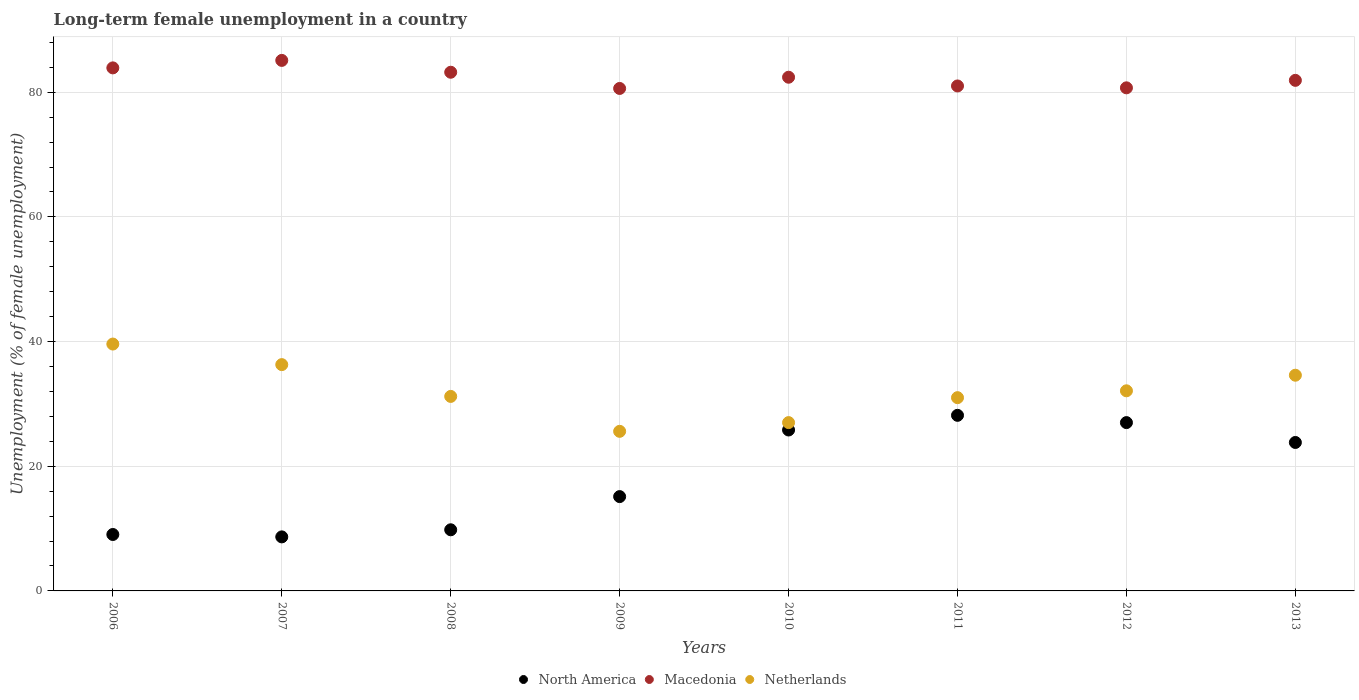How many different coloured dotlines are there?
Make the answer very short. 3. Is the number of dotlines equal to the number of legend labels?
Keep it short and to the point. Yes. What is the percentage of long-term unemployed female population in Macedonia in 2009?
Keep it short and to the point. 80.6. Across all years, what is the maximum percentage of long-term unemployed female population in Macedonia?
Your response must be concise. 85.1. Across all years, what is the minimum percentage of long-term unemployed female population in North America?
Your response must be concise. 8.67. In which year was the percentage of long-term unemployed female population in Netherlands maximum?
Your answer should be very brief. 2006. What is the total percentage of long-term unemployed female population in North America in the graph?
Your response must be concise. 147.45. What is the difference between the percentage of long-term unemployed female population in North America in 2010 and that in 2011?
Give a very brief answer. -2.35. What is the difference between the percentage of long-term unemployed female population in North America in 2006 and the percentage of long-term unemployed female population in Netherlands in 2008?
Your answer should be very brief. -22.15. What is the average percentage of long-term unemployed female population in Netherlands per year?
Ensure brevity in your answer.  32.17. In the year 2007, what is the difference between the percentage of long-term unemployed female population in Netherlands and percentage of long-term unemployed female population in North America?
Your answer should be very brief. 27.63. In how many years, is the percentage of long-term unemployed female population in North America greater than 32 %?
Your answer should be very brief. 0. What is the ratio of the percentage of long-term unemployed female population in Netherlands in 2012 to that in 2013?
Provide a short and direct response. 0.93. Is the percentage of long-term unemployed female population in Netherlands in 2006 less than that in 2012?
Your answer should be very brief. No. What is the difference between the highest and the second highest percentage of long-term unemployed female population in North America?
Offer a very short reply. 1.17. What is the difference between the highest and the lowest percentage of long-term unemployed female population in Netherlands?
Give a very brief answer. 14. Is the sum of the percentage of long-term unemployed female population in North America in 2008 and 2013 greater than the maximum percentage of long-term unemployed female population in Netherlands across all years?
Your response must be concise. No. Is the percentage of long-term unemployed female population in North America strictly less than the percentage of long-term unemployed female population in Macedonia over the years?
Provide a short and direct response. Yes. What is the difference between two consecutive major ticks on the Y-axis?
Offer a terse response. 20. Are the values on the major ticks of Y-axis written in scientific E-notation?
Keep it short and to the point. No. Does the graph contain any zero values?
Your answer should be very brief. No. Where does the legend appear in the graph?
Ensure brevity in your answer.  Bottom center. How many legend labels are there?
Provide a short and direct response. 3. How are the legend labels stacked?
Your answer should be compact. Horizontal. What is the title of the graph?
Make the answer very short. Long-term female unemployment in a country. What is the label or title of the Y-axis?
Provide a short and direct response. Unemployment (% of female unemployment). What is the Unemployment (% of female unemployment) in North America in 2006?
Give a very brief answer. 9.05. What is the Unemployment (% of female unemployment) in Macedonia in 2006?
Provide a short and direct response. 83.9. What is the Unemployment (% of female unemployment) in Netherlands in 2006?
Your answer should be very brief. 39.6. What is the Unemployment (% of female unemployment) of North America in 2007?
Offer a very short reply. 8.67. What is the Unemployment (% of female unemployment) in Macedonia in 2007?
Keep it short and to the point. 85.1. What is the Unemployment (% of female unemployment) of Netherlands in 2007?
Provide a succinct answer. 36.3. What is the Unemployment (% of female unemployment) in North America in 2008?
Provide a succinct answer. 9.81. What is the Unemployment (% of female unemployment) in Macedonia in 2008?
Offer a very short reply. 83.2. What is the Unemployment (% of female unemployment) in Netherlands in 2008?
Give a very brief answer. 31.2. What is the Unemployment (% of female unemployment) of North America in 2009?
Your response must be concise. 15.13. What is the Unemployment (% of female unemployment) in Macedonia in 2009?
Give a very brief answer. 80.6. What is the Unemployment (% of female unemployment) of Netherlands in 2009?
Provide a short and direct response. 25.6. What is the Unemployment (% of female unemployment) of North America in 2010?
Your answer should be very brief. 25.81. What is the Unemployment (% of female unemployment) of Macedonia in 2010?
Your response must be concise. 82.4. What is the Unemployment (% of female unemployment) in Netherlands in 2010?
Make the answer very short. 27. What is the Unemployment (% of female unemployment) in North America in 2011?
Your answer should be very brief. 28.17. What is the Unemployment (% of female unemployment) of Macedonia in 2011?
Your answer should be very brief. 81. What is the Unemployment (% of female unemployment) in North America in 2012?
Provide a succinct answer. 27. What is the Unemployment (% of female unemployment) of Macedonia in 2012?
Provide a short and direct response. 80.7. What is the Unemployment (% of female unemployment) in Netherlands in 2012?
Your answer should be compact. 32.1. What is the Unemployment (% of female unemployment) in North America in 2013?
Offer a terse response. 23.81. What is the Unemployment (% of female unemployment) of Macedonia in 2013?
Ensure brevity in your answer.  81.9. What is the Unemployment (% of female unemployment) in Netherlands in 2013?
Offer a very short reply. 34.6. Across all years, what is the maximum Unemployment (% of female unemployment) in North America?
Make the answer very short. 28.17. Across all years, what is the maximum Unemployment (% of female unemployment) in Macedonia?
Offer a terse response. 85.1. Across all years, what is the maximum Unemployment (% of female unemployment) in Netherlands?
Offer a terse response. 39.6. Across all years, what is the minimum Unemployment (% of female unemployment) of North America?
Offer a terse response. 8.67. Across all years, what is the minimum Unemployment (% of female unemployment) in Macedonia?
Provide a short and direct response. 80.6. Across all years, what is the minimum Unemployment (% of female unemployment) of Netherlands?
Provide a short and direct response. 25.6. What is the total Unemployment (% of female unemployment) of North America in the graph?
Keep it short and to the point. 147.45. What is the total Unemployment (% of female unemployment) of Macedonia in the graph?
Ensure brevity in your answer.  658.8. What is the total Unemployment (% of female unemployment) of Netherlands in the graph?
Offer a very short reply. 257.4. What is the difference between the Unemployment (% of female unemployment) of North America in 2006 and that in 2007?
Offer a terse response. 0.38. What is the difference between the Unemployment (% of female unemployment) of Macedonia in 2006 and that in 2007?
Your answer should be very brief. -1.2. What is the difference between the Unemployment (% of female unemployment) in Netherlands in 2006 and that in 2007?
Provide a short and direct response. 3.3. What is the difference between the Unemployment (% of female unemployment) in North America in 2006 and that in 2008?
Your answer should be compact. -0.75. What is the difference between the Unemployment (% of female unemployment) of North America in 2006 and that in 2009?
Offer a terse response. -6.08. What is the difference between the Unemployment (% of female unemployment) of Macedonia in 2006 and that in 2009?
Your answer should be compact. 3.3. What is the difference between the Unemployment (% of female unemployment) of North America in 2006 and that in 2010?
Your answer should be very brief. -16.76. What is the difference between the Unemployment (% of female unemployment) in North America in 2006 and that in 2011?
Offer a very short reply. -19.11. What is the difference between the Unemployment (% of female unemployment) in North America in 2006 and that in 2012?
Your answer should be compact. -17.95. What is the difference between the Unemployment (% of female unemployment) in Netherlands in 2006 and that in 2012?
Give a very brief answer. 7.5. What is the difference between the Unemployment (% of female unemployment) in North America in 2006 and that in 2013?
Offer a terse response. -14.76. What is the difference between the Unemployment (% of female unemployment) of Netherlands in 2006 and that in 2013?
Give a very brief answer. 5. What is the difference between the Unemployment (% of female unemployment) of North America in 2007 and that in 2008?
Offer a terse response. -1.14. What is the difference between the Unemployment (% of female unemployment) in Macedonia in 2007 and that in 2008?
Your answer should be compact. 1.9. What is the difference between the Unemployment (% of female unemployment) in Netherlands in 2007 and that in 2008?
Your answer should be very brief. 5.1. What is the difference between the Unemployment (% of female unemployment) of North America in 2007 and that in 2009?
Provide a short and direct response. -6.46. What is the difference between the Unemployment (% of female unemployment) in North America in 2007 and that in 2010?
Offer a very short reply. -17.15. What is the difference between the Unemployment (% of female unemployment) in Macedonia in 2007 and that in 2010?
Keep it short and to the point. 2.7. What is the difference between the Unemployment (% of female unemployment) in North America in 2007 and that in 2011?
Give a very brief answer. -19.5. What is the difference between the Unemployment (% of female unemployment) of North America in 2007 and that in 2012?
Your answer should be compact. -18.33. What is the difference between the Unemployment (% of female unemployment) in North America in 2007 and that in 2013?
Give a very brief answer. -15.14. What is the difference between the Unemployment (% of female unemployment) of Macedonia in 2007 and that in 2013?
Offer a very short reply. 3.2. What is the difference between the Unemployment (% of female unemployment) of Netherlands in 2007 and that in 2013?
Provide a short and direct response. 1.7. What is the difference between the Unemployment (% of female unemployment) in North America in 2008 and that in 2009?
Make the answer very short. -5.32. What is the difference between the Unemployment (% of female unemployment) of Macedonia in 2008 and that in 2009?
Ensure brevity in your answer.  2.6. What is the difference between the Unemployment (% of female unemployment) in North America in 2008 and that in 2010?
Offer a very short reply. -16.01. What is the difference between the Unemployment (% of female unemployment) in Macedonia in 2008 and that in 2010?
Your answer should be compact. 0.8. What is the difference between the Unemployment (% of female unemployment) in Netherlands in 2008 and that in 2010?
Provide a short and direct response. 4.2. What is the difference between the Unemployment (% of female unemployment) of North America in 2008 and that in 2011?
Your response must be concise. -18.36. What is the difference between the Unemployment (% of female unemployment) in Macedonia in 2008 and that in 2011?
Your response must be concise. 2.2. What is the difference between the Unemployment (% of female unemployment) of Netherlands in 2008 and that in 2011?
Keep it short and to the point. 0.2. What is the difference between the Unemployment (% of female unemployment) in North America in 2008 and that in 2012?
Your answer should be compact. -17.19. What is the difference between the Unemployment (% of female unemployment) in Macedonia in 2008 and that in 2012?
Make the answer very short. 2.5. What is the difference between the Unemployment (% of female unemployment) in North America in 2008 and that in 2013?
Provide a short and direct response. -14.01. What is the difference between the Unemployment (% of female unemployment) of Netherlands in 2008 and that in 2013?
Provide a succinct answer. -3.4. What is the difference between the Unemployment (% of female unemployment) of North America in 2009 and that in 2010?
Your response must be concise. -10.69. What is the difference between the Unemployment (% of female unemployment) of Netherlands in 2009 and that in 2010?
Your response must be concise. -1.4. What is the difference between the Unemployment (% of female unemployment) of North America in 2009 and that in 2011?
Offer a terse response. -13.04. What is the difference between the Unemployment (% of female unemployment) of Macedonia in 2009 and that in 2011?
Your response must be concise. -0.4. What is the difference between the Unemployment (% of female unemployment) in North America in 2009 and that in 2012?
Your answer should be very brief. -11.87. What is the difference between the Unemployment (% of female unemployment) of Netherlands in 2009 and that in 2012?
Offer a terse response. -6.5. What is the difference between the Unemployment (% of female unemployment) of North America in 2009 and that in 2013?
Your answer should be compact. -8.68. What is the difference between the Unemployment (% of female unemployment) in Netherlands in 2009 and that in 2013?
Offer a very short reply. -9. What is the difference between the Unemployment (% of female unemployment) of North America in 2010 and that in 2011?
Your answer should be compact. -2.35. What is the difference between the Unemployment (% of female unemployment) of Netherlands in 2010 and that in 2011?
Make the answer very short. -4. What is the difference between the Unemployment (% of female unemployment) in North America in 2010 and that in 2012?
Keep it short and to the point. -1.18. What is the difference between the Unemployment (% of female unemployment) in Netherlands in 2010 and that in 2012?
Ensure brevity in your answer.  -5.1. What is the difference between the Unemployment (% of female unemployment) of North America in 2010 and that in 2013?
Provide a short and direct response. 2. What is the difference between the Unemployment (% of female unemployment) of North America in 2011 and that in 2012?
Your answer should be compact. 1.17. What is the difference between the Unemployment (% of female unemployment) of North America in 2011 and that in 2013?
Offer a terse response. 4.35. What is the difference between the Unemployment (% of female unemployment) of North America in 2012 and that in 2013?
Ensure brevity in your answer.  3.19. What is the difference between the Unemployment (% of female unemployment) in Macedonia in 2012 and that in 2013?
Give a very brief answer. -1.2. What is the difference between the Unemployment (% of female unemployment) of Netherlands in 2012 and that in 2013?
Offer a very short reply. -2.5. What is the difference between the Unemployment (% of female unemployment) in North America in 2006 and the Unemployment (% of female unemployment) in Macedonia in 2007?
Your answer should be very brief. -76.05. What is the difference between the Unemployment (% of female unemployment) of North America in 2006 and the Unemployment (% of female unemployment) of Netherlands in 2007?
Your answer should be compact. -27.25. What is the difference between the Unemployment (% of female unemployment) of Macedonia in 2006 and the Unemployment (% of female unemployment) of Netherlands in 2007?
Your answer should be compact. 47.6. What is the difference between the Unemployment (% of female unemployment) of North America in 2006 and the Unemployment (% of female unemployment) of Macedonia in 2008?
Provide a succinct answer. -74.15. What is the difference between the Unemployment (% of female unemployment) of North America in 2006 and the Unemployment (% of female unemployment) of Netherlands in 2008?
Provide a short and direct response. -22.15. What is the difference between the Unemployment (% of female unemployment) of Macedonia in 2006 and the Unemployment (% of female unemployment) of Netherlands in 2008?
Give a very brief answer. 52.7. What is the difference between the Unemployment (% of female unemployment) of North America in 2006 and the Unemployment (% of female unemployment) of Macedonia in 2009?
Provide a short and direct response. -71.55. What is the difference between the Unemployment (% of female unemployment) of North America in 2006 and the Unemployment (% of female unemployment) of Netherlands in 2009?
Make the answer very short. -16.55. What is the difference between the Unemployment (% of female unemployment) of Macedonia in 2006 and the Unemployment (% of female unemployment) of Netherlands in 2009?
Offer a very short reply. 58.3. What is the difference between the Unemployment (% of female unemployment) in North America in 2006 and the Unemployment (% of female unemployment) in Macedonia in 2010?
Provide a short and direct response. -73.35. What is the difference between the Unemployment (% of female unemployment) of North America in 2006 and the Unemployment (% of female unemployment) of Netherlands in 2010?
Your answer should be compact. -17.95. What is the difference between the Unemployment (% of female unemployment) of Macedonia in 2006 and the Unemployment (% of female unemployment) of Netherlands in 2010?
Provide a short and direct response. 56.9. What is the difference between the Unemployment (% of female unemployment) in North America in 2006 and the Unemployment (% of female unemployment) in Macedonia in 2011?
Provide a succinct answer. -71.95. What is the difference between the Unemployment (% of female unemployment) of North America in 2006 and the Unemployment (% of female unemployment) of Netherlands in 2011?
Give a very brief answer. -21.95. What is the difference between the Unemployment (% of female unemployment) in Macedonia in 2006 and the Unemployment (% of female unemployment) in Netherlands in 2011?
Provide a succinct answer. 52.9. What is the difference between the Unemployment (% of female unemployment) in North America in 2006 and the Unemployment (% of female unemployment) in Macedonia in 2012?
Give a very brief answer. -71.65. What is the difference between the Unemployment (% of female unemployment) of North America in 2006 and the Unemployment (% of female unemployment) of Netherlands in 2012?
Your response must be concise. -23.05. What is the difference between the Unemployment (% of female unemployment) of Macedonia in 2006 and the Unemployment (% of female unemployment) of Netherlands in 2012?
Ensure brevity in your answer.  51.8. What is the difference between the Unemployment (% of female unemployment) in North America in 2006 and the Unemployment (% of female unemployment) in Macedonia in 2013?
Give a very brief answer. -72.85. What is the difference between the Unemployment (% of female unemployment) in North America in 2006 and the Unemployment (% of female unemployment) in Netherlands in 2013?
Provide a short and direct response. -25.55. What is the difference between the Unemployment (% of female unemployment) of Macedonia in 2006 and the Unemployment (% of female unemployment) of Netherlands in 2013?
Give a very brief answer. 49.3. What is the difference between the Unemployment (% of female unemployment) of North America in 2007 and the Unemployment (% of female unemployment) of Macedonia in 2008?
Offer a terse response. -74.53. What is the difference between the Unemployment (% of female unemployment) of North America in 2007 and the Unemployment (% of female unemployment) of Netherlands in 2008?
Your answer should be compact. -22.53. What is the difference between the Unemployment (% of female unemployment) of Macedonia in 2007 and the Unemployment (% of female unemployment) of Netherlands in 2008?
Your answer should be very brief. 53.9. What is the difference between the Unemployment (% of female unemployment) in North America in 2007 and the Unemployment (% of female unemployment) in Macedonia in 2009?
Provide a succinct answer. -71.93. What is the difference between the Unemployment (% of female unemployment) in North America in 2007 and the Unemployment (% of female unemployment) in Netherlands in 2009?
Ensure brevity in your answer.  -16.93. What is the difference between the Unemployment (% of female unemployment) in Macedonia in 2007 and the Unemployment (% of female unemployment) in Netherlands in 2009?
Keep it short and to the point. 59.5. What is the difference between the Unemployment (% of female unemployment) of North America in 2007 and the Unemployment (% of female unemployment) of Macedonia in 2010?
Your answer should be compact. -73.73. What is the difference between the Unemployment (% of female unemployment) in North America in 2007 and the Unemployment (% of female unemployment) in Netherlands in 2010?
Provide a succinct answer. -18.33. What is the difference between the Unemployment (% of female unemployment) of Macedonia in 2007 and the Unemployment (% of female unemployment) of Netherlands in 2010?
Keep it short and to the point. 58.1. What is the difference between the Unemployment (% of female unemployment) in North America in 2007 and the Unemployment (% of female unemployment) in Macedonia in 2011?
Offer a terse response. -72.33. What is the difference between the Unemployment (% of female unemployment) in North America in 2007 and the Unemployment (% of female unemployment) in Netherlands in 2011?
Your answer should be compact. -22.33. What is the difference between the Unemployment (% of female unemployment) in Macedonia in 2007 and the Unemployment (% of female unemployment) in Netherlands in 2011?
Provide a succinct answer. 54.1. What is the difference between the Unemployment (% of female unemployment) in North America in 2007 and the Unemployment (% of female unemployment) in Macedonia in 2012?
Keep it short and to the point. -72.03. What is the difference between the Unemployment (% of female unemployment) in North America in 2007 and the Unemployment (% of female unemployment) in Netherlands in 2012?
Keep it short and to the point. -23.43. What is the difference between the Unemployment (% of female unemployment) in North America in 2007 and the Unemployment (% of female unemployment) in Macedonia in 2013?
Provide a succinct answer. -73.23. What is the difference between the Unemployment (% of female unemployment) in North America in 2007 and the Unemployment (% of female unemployment) in Netherlands in 2013?
Your answer should be compact. -25.93. What is the difference between the Unemployment (% of female unemployment) of Macedonia in 2007 and the Unemployment (% of female unemployment) of Netherlands in 2013?
Provide a short and direct response. 50.5. What is the difference between the Unemployment (% of female unemployment) of North America in 2008 and the Unemployment (% of female unemployment) of Macedonia in 2009?
Keep it short and to the point. -70.79. What is the difference between the Unemployment (% of female unemployment) of North America in 2008 and the Unemployment (% of female unemployment) of Netherlands in 2009?
Offer a terse response. -15.79. What is the difference between the Unemployment (% of female unemployment) in Macedonia in 2008 and the Unemployment (% of female unemployment) in Netherlands in 2009?
Your response must be concise. 57.6. What is the difference between the Unemployment (% of female unemployment) of North America in 2008 and the Unemployment (% of female unemployment) of Macedonia in 2010?
Make the answer very short. -72.59. What is the difference between the Unemployment (% of female unemployment) of North America in 2008 and the Unemployment (% of female unemployment) of Netherlands in 2010?
Your answer should be very brief. -17.19. What is the difference between the Unemployment (% of female unemployment) in Macedonia in 2008 and the Unemployment (% of female unemployment) in Netherlands in 2010?
Offer a terse response. 56.2. What is the difference between the Unemployment (% of female unemployment) of North America in 2008 and the Unemployment (% of female unemployment) of Macedonia in 2011?
Provide a succinct answer. -71.19. What is the difference between the Unemployment (% of female unemployment) in North America in 2008 and the Unemployment (% of female unemployment) in Netherlands in 2011?
Provide a succinct answer. -21.19. What is the difference between the Unemployment (% of female unemployment) of Macedonia in 2008 and the Unemployment (% of female unemployment) of Netherlands in 2011?
Your answer should be compact. 52.2. What is the difference between the Unemployment (% of female unemployment) of North America in 2008 and the Unemployment (% of female unemployment) of Macedonia in 2012?
Make the answer very short. -70.89. What is the difference between the Unemployment (% of female unemployment) of North America in 2008 and the Unemployment (% of female unemployment) of Netherlands in 2012?
Give a very brief answer. -22.29. What is the difference between the Unemployment (% of female unemployment) in Macedonia in 2008 and the Unemployment (% of female unemployment) in Netherlands in 2012?
Give a very brief answer. 51.1. What is the difference between the Unemployment (% of female unemployment) in North America in 2008 and the Unemployment (% of female unemployment) in Macedonia in 2013?
Ensure brevity in your answer.  -72.09. What is the difference between the Unemployment (% of female unemployment) of North America in 2008 and the Unemployment (% of female unemployment) of Netherlands in 2013?
Make the answer very short. -24.79. What is the difference between the Unemployment (% of female unemployment) in Macedonia in 2008 and the Unemployment (% of female unemployment) in Netherlands in 2013?
Your answer should be very brief. 48.6. What is the difference between the Unemployment (% of female unemployment) of North America in 2009 and the Unemployment (% of female unemployment) of Macedonia in 2010?
Your answer should be very brief. -67.27. What is the difference between the Unemployment (% of female unemployment) in North America in 2009 and the Unemployment (% of female unemployment) in Netherlands in 2010?
Give a very brief answer. -11.87. What is the difference between the Unemployment (% of female unemployment) of Macedonia in 2009 and the Unemployment (% of female unemployment) of Netherlands in 2010?
Provide a short and direct response. 53.6. What is the difference between the Unemployment (% of female unemployment) in North America in 2009 and the Unemployment (% of female unemployment) in Macedonia in 2011?
Offer a terse response. -65.87. What is the difference between the Unemployment (% of female unemployment) of North America in 2009 and the Unemployment (% of female unemployment) of Netherlands in 2011?
Your response must be concise. -15.87. What is the difference between the Unemployment (% of female unemployment) in Macedonia in 2009 and the Unemployment (% of female unemployment) in Netherlands in 2011?
Give a very brief answer. 49.6. What is the difference between the Unemployment (% of female unemployment) of North America in 2009 and the Unemployment (% of female unemployment) of Macedonia in 2012?
Offer a terse response. -65.57. What is the difference between the Unemployment (% of female unemployment) in North America in 2009 and the Unemployment (% of female unemployment) in Netherlands in 2012?
Your answer should be very brief. -16.97. What is the difference between the Unemployment (% of female unemployment) of Macedonia in 2009 and the Unemployment (% of female unemployment) of Netherlands in 2012?
Make the answer very short. 48.5. What is the difference between the Unemployment (% of female unemployment) in North America in 2009 and the Unemployment (% of female unemployment) in Macedonia in 2013?
Provide a short and direct response. -66.77. What is the difference between the Unemployment (% of female unemployment) of North America in 2009 and the Unemployment (% of female unemployment) of Netherlands in 2013?
Your answer should be compact. -19.47. What is the difference between the Unemployment (% of female unemployment) in Macedonia in 2009 and the Unemployment (% of female unemployment) in Netherlands in 2013?
Offer a terse response. 46. What is the difference between the Unemployment (% of female unemployment) in North America in 2010 and the Unemployment (% of female unemployment) in Macedonia in 2011?
Provide a succinct answer. -55.19. What is the difference between the Unemployment (% of female unemployment) in North America in 2010 and the Unemployment (% of female unemployment) in Netherlands in 2011?
Keep it short and to the point. -5.19. What is the difference between the Unemployment (% of female unemployment) in Macedonia in 2010 and the Unemployment (% of female unemployment) in Netherlands in 2011?
Keep it short and to the point. 51.4. What is the difference between the Unemployment (% of female unemployment) in North America in 2010 and the Unemployment (% of female unemployment) in Macedonia in 2012?
Offer a very short reply. -54.89. What is the difference between the Unemployment (% of female unemployment) of North America in 2010 and the Unemployment (% of female unemployment) of Netherlands in 2012?
Offer a very short reply. -6.29. What is the difference between the Unemployment (% of female unemployment) in Macedonia in 2010 and the Unemployment (% of female unemployment) in Netherlands in 2012?
Provide a succinct answer. 50.3. What is the difference between the Unemployment (% of female unemployment) in North America in 2010 and the Unemployment (% of female unemployment) in Macedonia in 2013?
Make the answer very short. -56.09. What is the difference between the Unemployment (% of female unemployment) in North America in 2010 and the Unemployment (% of female unemployment) in Netherlands in 2013?
Make the answer very short. -8.79. What is the difference between the Unemployment (% of female unemployment) in Macedonia in 2010 and the Unemployment (% of female unemployment) in Netherlands in 2013?
Offer a terse response. 47.8. What is the difference between the Unemployment (% of female unemployment) in North America in 2011 and the Unemployment (% of female unemployment) in Macedonia in 2012?
Give a very brief answer. -52.53. What is the difference between the Unemployment (% of female unemployment) of North America in 2011 and the Unemployment (% of female unemployment) of Netherlands in 2012?
Make the answer very short. -3.93. What is the difference between the Unemployment (% of female unemployment) of Macedonia in 2011 and the Unemployment (% of female unemployment) of Netherlands in 2012?
Your answer should be compact. 48.9. What is the difference between the Unemployment (% of female unemployment) of North America in 2011 and the Unemployment (% of female unemployment) of Macedonia in 2013?
Your response must be concise. -53.73. What is the difference between the Unemployment (% of female unemployment) of North America in 2011 and the Unemployment (% of female unemployment) of Netherlands in 2013?
Provide a succinct answer. -6.43. What is the difference between the Unemployment (% of female unemployment) of Macedonia in 2011 and the Unemployment (% of female unemployment) of Netherlands in 2013?
Give a very brief answer. 46.4. What is the difference between the Unemployment (% of female unemployment) in North America in 2012 and the Unemployment (% of female unemployment) in Macedonia in 2013?
Offer a very short reply. -54.9. What is the difference between the Unemployment (% of female unemployment) in North America in 2012 and the Unemployment (% of female unemployment) in Netherlands in 2013?
Provide a short and direct response. -7.6. What is the difference between the Unemployment (% of female unemployment) of Macedonia in 2012 and the Unemployment (% of female unemployment) of Netherlands in 2013?
Your answer should be compact. 46.1. What is the average Unemployment (% of female unemployment) of North America per year?
Keep it short and to the point. 18.43. What is the average Unemployment (% of female unemployment) in Macedonia per year?
Your answer should be compact. 82.35. What is the average Unemployment (% of female unemployment) in Netherlands per year?
Your response must be concise. 32.17. In the year 2006, what is the difference between the Unemployment (% of female unemployment) in North America and Unemployment (% of female unemployment) in Macedonia?
Your response must be concise. -74.85. In the year 2006, what is the difference between the Unemployment (% of female unemployment) of North America and Unemployment (% of female unemployment) of Netherlands?
Ensure brevity in your answer.  -30.55. In the year 2006, what is the difference between the Unemployment (% of female unemployment) in Macedonia and Unemployment (% of female unemployment) in Netherlands?
Your answer should be very brief. 44.3. In the year 2007, what is the difference between the Unemployment (% of female unemployment) of North America and Unemployment (% of female unemployment) of Macedonia?
Offer a very short reply. -76.43. In the year 2007, what is the difference between the Unemployment (% of female unemployment) in North America and Unemployment (% of female unemployment) in Netherlands?
Offer a terse response. -27.63. In the year 2007, what is the difference between the Unemployment (% of female unemployment) in Macedonia and Unemployment (% of female unemployment) in Netherlands?
Offer a terse response. 48.8. In the year 2008, what is the difference between the Unemployment (% of female unemployment) of North America and Unemployment (% of female unemployment) of Macedonia?
Give a very brief answer. -73.39. In the year 2008, what is the difference between the Unemployment (% of female unemployment) of North America and Unemployment (% of female unemployment) of Netherlands?
Keep it short and to the point. -21.39. In the year 2008, what is the difference between the Unemployment (% of female unemployment) of Macedonia and Unemployment (% of female unemployment) of Netherlands?
Make the answer very short. 52. In the year 2009, what is the difference between the Unemployment (% of female unemployment) in North America and Unemployment (% of female unemployment) in Macedonia?
Your answer should be compact. -65.47. In the year 2009, what is the difference between the Unemployment (% of female unemployment) of North America and Unemployment (% of female unemployment) of Netherlands?
Provide a short and direct response. -10.47. In the year 2010, what is the difference between the Unemployment (% of female unemployment) in North America and Unemployment (% of female unemployment) in Macedonia?
Ensure brevity in your answer.  -56.59. In the year 2010, what is the difference between the Unemployment (% of female unemployment) of North America and Unemployment (% of female unemployment) of Netherlands?
Ensure brevity in your answer.  -1.19. In the year 2010, what is the difference between the Unemployment (% of female unemployment) in Macedonia and Unemployment (% of female unemployment) in Netherlands?
Make the answer very short. 55.4. In the year 2011, what is the difference between the Unemployment (% of female unemployment) of North America and Unemployment (% of female unemployment) of Macedonia?
Your response must be concise. -52.83. In the year 2011, what is the difference between the Unemployment (% of female unemployment) in North America and Unemployment (% of female unemployment) in Netherlands?
Provide a succinct answer. -2.83. In the year 2012, what is the difference between the Unemployment (% of female unemployment) in North America and Unemployment (% of female unemployment) in Macedonia?
Give a very brief answer. -53.7. In the year 2012, what is the difference between the Unemployment (% of female unemployment) in North America and Unemployment (% of female unemployment) in Netherlands?
Provide a succinct answer. -5.1. In the year 2012, what is the difference between the Unemployment (% of female unemployment) in Macedonia and Unemployment (% of female unemployment) in Netherlands?
Make the answer very short. 48.6. In the year 2013, what is the difference between the Unemployment (% of female unemployment) of North America and Unemployment (% of female unemployment) of Macedonia?
Your answer should be very brief. -58.09. In the year 2013, what is the difference between the Unemployment (% of female unemployment) in North America and Unemployment (% of female unemployment) in Netherlands?
Keep it short and to the point. -10.79. In the year 2013, what is the difference between the Unemployment (% of female unemployment) of Macedonia and Unemployment (% of female unemployment) of Netherlands?
Provide a short and direct response. 47.3. What is the ratio of the Unemployment (% of female unemployment) in North America in 2006 to that in 2007?
Ensure brevity in your answer.  1.04. What is the ratio of the Unemployment (% of female unemployment) of Macedonia in 2006 to that in 2007?
Your answer should be compact. 0.99. What is the ratio of the Unemployment (% of female unemployment) of Macedonia in 2006 to that in 2008?
Provide a succinct answer. 1.01. What is the ratio of the Unemployment (% of female unemployment) in Netherlands in 2006 to that in 2008?
Offer a terse response. 1.27. What is the ratio of the Unemployment (% of female unemployment) of North America in 2006 to that in 2009?
Make the answer very short. 0.6. What is the ratio of the Unemployment (% of female unemployment) in Macedonia in 2006 to that in 2009?
Provide a succinct answer. 1.04. What is the ratio of the Unemployment (% of female unemployment) of Netherlands in 2006 to that in 2009?
Give a very brief answer. 1.55. What is the ratio of the Unemployment (% of female unemployment) of North America in 2006 to that in 2010?
Keep it short and to the point. 0.35. What is the ratio of the Unemployment (% of female unemployment) in Macedonia in 2006 to that in 2010?
Give a very brief answer. 1.02. What is the ratio of the Unemployment (% of female unemployment) of Netherlands in 2006 to that in 2010?
Your answer should be very brief. 1.47. What is the ratio of the Unemployment (% of female unemployment) of North America in 2006 to that in 2011?
Ensure brevity in your answer.  0.32. What is the ratio of the Unemployment (% of female unemployment) in Macedonia in 2006 to that in 2011?
Ensure brevity in your answer.  1.04. What is the ratio of the Unemployment (% of female unemployment) in Netherlands in 2006 to that in 2011?
Your answer should be very brief. 1.28. What is the ratio of the Unemployment (% of female unemployment) in North America in 2006 to that in 2012?
Ensure brevity in your answer.  0.34. What is the ratio of the Unemployment (% of female unemployment) in Macedonia in 2006 to that in 2012?
Provide a short and direct response. 1.04. What is the ratio of the Unemployment (% of female unemployment) in Netherlands in 2006 to that in 2012?
Provide a short and direct response. 1.23. What is the ratio of the Unemployment (% of female unemployment) in North America in 2006 to that in 2013?
Your answer should be very brief. 0.38. What is the ratio of the Unemployment (% of female unemployment) in Macedonia in 2006 to that in 2013?
Offer a terse response. 1.02. What is the ratio of the Unemployment (% of female unemployment) of Netherlands in 2006 to that in 2013?
Make the answer very short. 1.14. What is the ratio of the Unemployment (% of female unemployment) in North America in 2007 to that in 2008?
Your answer should be very brief. 0.88. What is the ratio of the Unemployment (% of female unemployment) in Macedonia in 2007 to that in 2008?
Ensure brevity in your answer.  1.02. What is the ratio of the Unemployment (% of female unemployment) in Netherlands in 2007 to that in 2008?
Your response must be concise. 1.16. What is the ratio of the Unemployment (% of female unemployment) of North America in 2007 to that in 2009?
Offer a terse response. 0.57. What is the ratio of the Unemployment (% of female unemployment) of Macedonia in 2007 to that in 2009?
Offer a terse response. 1.06. What is the ratio of the Unemployment (% of female unemployment) of Netherlands in 2007 to that in 2009?
Keep it short and to the point. 1.42. What is the ratio of the Unemployment (% of female unemployment) in North America in 2007 to that in 2010?
Provide a succinct answer. 0.34. What is the ratio of the Unemployment (% of female unemployment) of Macedonia in 2007 to that in 2010?
Keep it short and to the point. 1.03. What is the ratio of the Unemployment (% of female unemployment) of Netherlands in 2007 to that in 2010?
Your response must be concise. 1.34. What is the ratio of the Unemployment (% of female unemployment) of North America in 2007 to that in 2011?
Give a very brief answer. 0.31. What is the ratio of the Unemployment (% of female unemployment) in Macedonia in 2007 to that in 2011?
Your answer should be compact. 1.05. What is the ratio of the Unemployment (% of female unemployment) in Netherlands in 2007 to that in 2011?
Your answer should be very brief. 1.17. What is the ratio of the Unemployment (% of female unemployment) of North America in 2007 to that in 2012?
Your response must be concise. 0.32. What is the ratio of the Unemployment (% of female unemployment) in Macedonia in 2007 to that in 2012?
Your response must be concise. 1.05. What is the ratio of the Unemployment (% of female unemployment) in Netherlands in 2007 to that in 2012?
Keep it short and to the point. 1.13. What is the ratio of the Unemployment (% of female unemployment) of North America in 2007 to that in 2013?
Provide a short and direct response. 0.36. What is the ratio of the Unemployment (% of female unemployment) of Macedonia in 2007 to that in 2013?
Make the answer very short. 1.04. What is the ratio of the Unemployment (% of female unemployment) of Netherlands in 2007 to that in 2013?
Ensure brevity in your answer.  1.05. What is the ratio of the Unemployment (% of female unemployment) of North America in 2008 to that in 2009?
Ensure brevity in your answer.  0.65. What is the ratio of the Unemployment (% of female unemployment) of Macedonia in 2008 to that in 2009?
Give a very brief answer. 1.03. What is the ratio of the Unemployment (% of female unemployment) in Netherlands in 2008 to that in 2009?
Give a very brief answer. 1.22. What is the ratio of the Unemployment (% of female unemployment) of North America in 2008 to that in 2010?
Offer a very short reply. 0.38. What is the ratio of the Unemployment (% of female unemployment) of Macedonia in 2008 to that in 2010?
Give a very brief answer. 1.01. What is the ratio of the Unemployment (% of female unemployment) of Netherlands in 2008 to that in 2010?
Make the answer very short. 1.16. What is the ratio of the Unemployment (% of female unemployment) of North America in 2008 to that in 2011?
Offer a very short reply. 0.35. What is the ratio of the Unemployment (% of female unemployment) of Macedonia in 2008 to that in 2011?
Your answer should be very brief. 1.03. What is the ratio of the Unemployment (% of female unemployment) in North America in 2008 to that in 2012?
Give a very brief answer. 0.36. What is the ratio of the Unemployment (% of female unemployment) of Macedonia in 2008 to that in 2012?
Give a very brief answer. 1.03. What is the ratio of the Unemployment (% of female unemployment) in Netherlands in 2008 to that in 2012?
Make the answer very short. 0.97. What is the ratio of the Unemployment (% of female unemployment) in North America in 2008 to that in 2013?
Ensure brevity in your answer.  0.41. What is the ratio of the Unemployment (% of female unemployment) of Macedonia in 2008 to that in 2013?
Make the answer very short. 1.02. What is the ratio of the Unemployment (% of female unemployment) of Netherlands in 2008 to that in 2013?
Keep it short and to the point. 0.9. What is the ratio of the Unemployment (% of female unemployment) in North America in 2009 to that in 2010?
Provide a succinct answer. 0.59. What is the ratio of the Unemployment (% of female unemployment) of Macedonia in 2009 to that in 2010?
Your answer should be compact. 0.98. What is the ratio of the Unemployment (% of female unemployment) in Netherlands in 2009 to that in 2010?
Keep it short and to the point. 0.95. What is the ratio of the Unemployment (% of female unemployment) in North America in 2009 to that in 2011?
Offer a very short reply. 0.54. What is the ratio of the Unemployment (% of female unemployment) of Macedonia in 2009 to that in 2011?
Make the answer very short. 1. What is the ratio of the Unemployment (% of female unemployment) of Netherlands in 2009 to that in 2011?
Your answer should be very brief. 0.83. What is the ratio of the Unemployment (% of female unemployment) in North America in 2009 to that in 2012?
Keep it short and to the point. 0.56. What is the ratio of the Unemployment (% of female unemployment) of Netherlands in 2009 to that in 2012?
Keep it short and to the point. 0.8. What is the ratio of the Unemployment (% of female unemployment) in North America in 2009 to that in 2013?
Your response must be concise. 0.64. What is the ratio of the Unemployment (% of female unemployment) of Macedonia in 2009 to that in 2013?
Your response must be concise. 0.98. What is the ratio of the Unemployment (% of female unemployment) of Netherlands in 2009 to that in 2013?
Your answer should be compact. 0.74. What is the ratio of the Unemployment (% of female unemployment) of North America in 2010 to that in 2011?
Your answer should be compact. 0.92. What is the ratio of the Unemployment (% of female unemployment) in Macedonia in 2010 to that in 2011?
Your answer should be very brief. 1.02. What is the ratio of the Unemployment (% of female unemployment) of Netherlands in 2010 to that in 2011?
Give a very brief answer. 0.87. What is the ratio of the Unemployment (% of female unemployment) of North America in 2010 to that in 2012?
Keep it short and to the point. 0.96. What is the ratio of the Unemployment (% of female unemployment) in Macedonia in 2010 to that in 2012?
Offer a very short reply. 1.02. What is the ratio of the Unemployment (% of female unemployment) of Netherlands in 2010 to that in 2012?
Provide a succinct answer. 0.84. What is the ratio of the Unemployment (% of female unemployment) of North America in 2010 to that in 2013?
Offer a terse response. 1.08. What is the ratio of the Unemployment (% of female unemployment) of Netherlands in 2010 to that in 2013?
Offer a very short reply. 0.78. What is the ratio of the Unemployment (% of female unemployment) in North America in 2011 to that in 2012?
Keep it short and to the point. 1.04. What is the ratio of the Unemployment (% of female unemployment) of Netherlands in 2011 to that in 2012?
Your answer should be very brief. 0.97. What is the ratio of the Unemployment (% of female unemployment) of North America in 2011 to that in 2013?
Your answer should be very brief. 1.18. What is the ratio of the Unemployment (% of female unemployment) in Macedonia in 2011 to that in 2013?
Make the answer very short. 0.99. What is the ratio of the Unemployment (% of female unemployment) in Netherlands in 2011 to that in 2013?
Provide a short and direct response. 0.9. What is the ratio of the Unemployment (% of female unemployment) in North America in 2012 to that in 2013?
Keep it short and to the point. 1.13. What is the ratio of the Unemployment (% of female unemployment) in Netherlands in 2012 to that in 2013?
Offer a very short reply. 0.93. What is the difference between the highest and the second highest Unemployment (% of female unemployment) in North America?
Give a very brief answer. 1.17. What is the difference between the highest and the second highest Unemployment (% of female unemployment) in Netherlands?
Ensure brevity in your answer.  3.3. What is the difference between the highest and the lowest Unemployment (% of female unemployment) of North America?
Your response must be concise. 19.5. What is the difference between the highest and the lowest Unemployment (% of female unemployment) of Macedonia?
Keep it short and to the point. 4.5. 